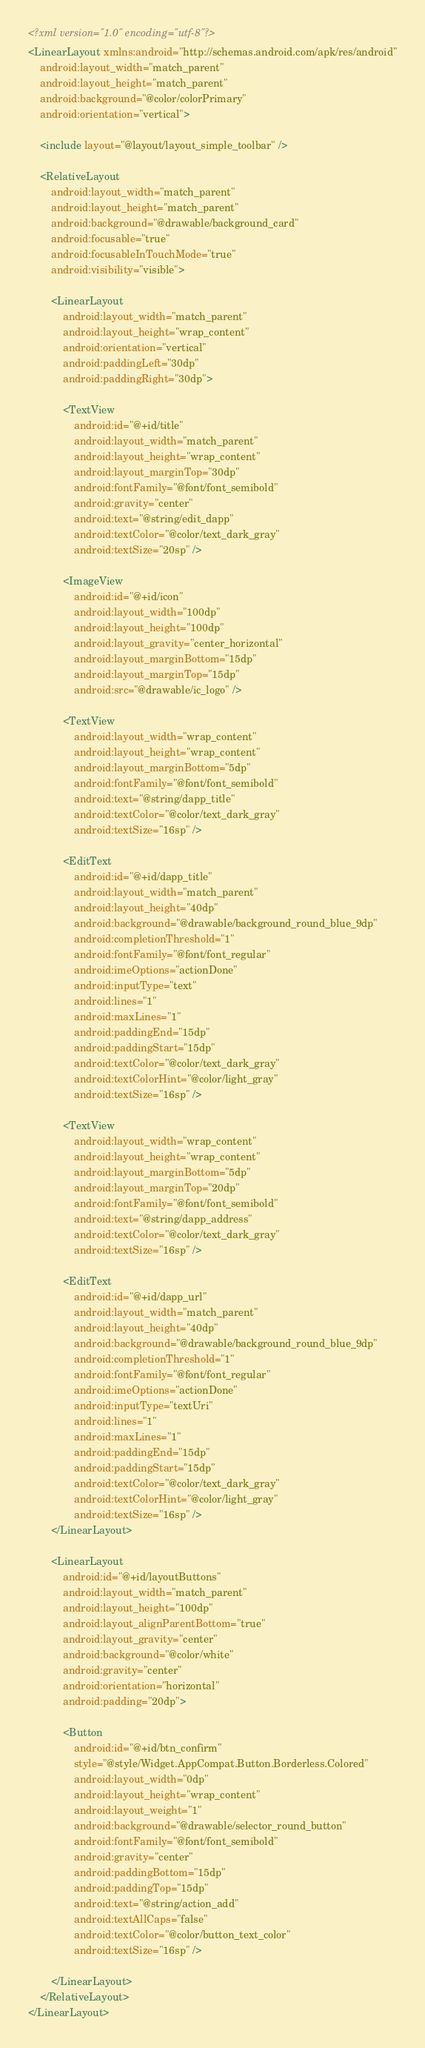<code> <loc_0><loc_0><loc_500><loc_500><_XML_><?xml version="1.0" encoding="utf-8"?>
<LinearLayout xmlns:android="http://schemas.android.com/apk/res/android"
    android:layout_width="match_parent"
    android:layout_height="match_parent"
    android:background="@color/colorPrimary"
    android:orientation="vertical">

    <include layout="@layout/layout_simple_toolbar" />

    <RelativeLayout
        android:layout_width="match_parent"
        android:layout_height="match_parent"
        android:background="@drawable/background_card"
        android:focusable="true"
        android:focusableInTouchMode="true"
        android:visibility="visible">

        <LinearLayout
            android:layout_width="match_parent"
            android:layout_height="wrap_content"
            android:orientation="vertical"
            android:paddingLeft="30dp"
            android:paddingRight="30dp">

            <TextView
                android:id="@+id/title"
                android:layout_width="match_parent"
                android:layout_height="wrap_content"
                android:layout_marginTop="30dp"
                android:fontFamily="@font/font_semibold"
                android:gravity="center"
                android:text="@string/edit_dapp"
                android:textColor="@color/text_dark_gray"
                android:textSize="20sp" />

            <ImageView
                android:id="@+id/icon"
                android:layout_width="100dp"
                android:layout_height="100dp"
                android:layout_gravity="center_horizontal"
                android:layout_marginBottom="15dp"
                android:layout_marginTop="15dp"
                android:src="@drawable/ic_logo" />

            <TextView
                android:layout_width="wrap_content"
                android:layout_height="wrap_content"
                android:layout_marginBottom="5dp"
                android:fontFamily="@font/font_semibold"
                android:text="@string/dapp_title"
                android:textColor="@color/text_dark_gray"
                android:textSize="16sp" />

            <EditText
                android:id="@+id/dapp_title"
                android:layout_width="match_parent"
                android:layout_height="40dp"
                android:background="@drawable/background_round_blue_9dp"
                android:completionThreshold="1"
                android:fontFamily="@font/font_regular"
                android:imeOptions="actionDone"
                android:inputType="text"
                android:lines="1"
                android:maxLines="1"
                android:paddingEnd="15dp"
                android:paddingStart="15dp"
                android:textColor="@color/text_dark_gray"
                android:textColorHint="@color/light_gray"
                android:textSize="16sp" />

            <TextView
                android:layout_width="wrap_content"
                android:layout_height="wrap_content"
                android:layout_marginBottom="5dp"
                android:layout_marginTop="20dp"
                android:fontFamily="@font/font_semibold"
                android:text="@string/dapp_address"
                android:textColor="@color/text_dark_gray"
                android:textSize="16sp" />

            <EditText
                android:id="@+id/dapp_url"
                android:layout_width="match_parent"
                android:layout_height="40dp"
                android:background="@drawable/background_round_blue_9dp"
                android:completionThreshold="1"
                android:fontFamily="@font/font_regular"
                android:imeOptions="actionDone"
                android:inputType="textUri"
                android:lines="1"
                android:maxLines="1"
                android:paddingEnd="15dp"
                android:paddingStart="15dp"
                android:textColor="@color/text_dark_gray"
                android:textColorHint="@color/light_gray"
                android:textSize="16sp" />
        </LinearLayout>

        <LinearLayout
            android:id="@+id/layoutButtons"
            android:layout_width="match_parent"
            android:layout_height="100dp"
            android:layout_alignParentBottom="true"
            android:layout_gravity="center"
            android:background="@color/white"
            android:gravity="center"
            android:orientation="horizontal"
            android:padding="20dp">

            <Button
                android:id="@+id/btn_confirm"
                style="@style/Widget.AppCompat.Button.Borderless.Colored"
                android:layout_width="0dp"
                android:layout_height="wrap_content"
                android:layout_weight="1"
                android:background="@drawable/selector_round_button"
                android:fontFamily="@font/font_semibold"
                android:gravity="center"
                android:paddingBottom="15dp"
                android:paddingTop="15dp"
                android:text="@string/action_add"
                android:textAllCaps="false"
                android:textColor="@color/button_text_color"
                android:textSize="16sp" />

        </LinearLayout>
    </RelativeLayout>
</LinearLayout>
</code> 